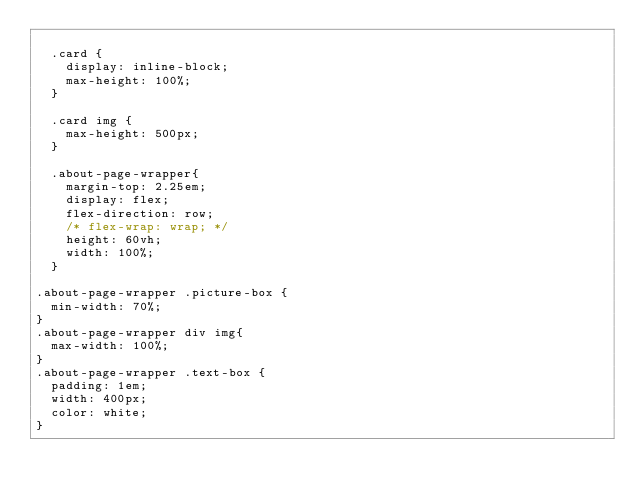<code> <loc_0><loc_0><loc_500><loc_500><_CSS_>
  .card {
    display: inline-block;
    max-height: 100%;
  }

  .card img {
    max-height: 500px;
  }

  .about-page-wrapper{
    margin-top: 2.25em;
    display: flex; 
    flex-direction: row;
    /* flex-wrap: wrap; */
    height: 60vh;
    width: 100%;
  }

.about-page-wrapper .picture-box {
  min-width: 70%;
}
.about-page-wrapper div img{
  max-width: 100%;
}
.about-page-wrapper .text-box {
  padding: 1em;
  width: 400px;
  color: white;
}</code> 